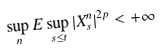Convert formula to latex. <formula><loc_0><loc_0><loc_500><loc_500>\sup _ { n } E \sup _ { s \leq t } | X ^ { n } _ { s } | ^ { 2 p } < + \infty</formula> 